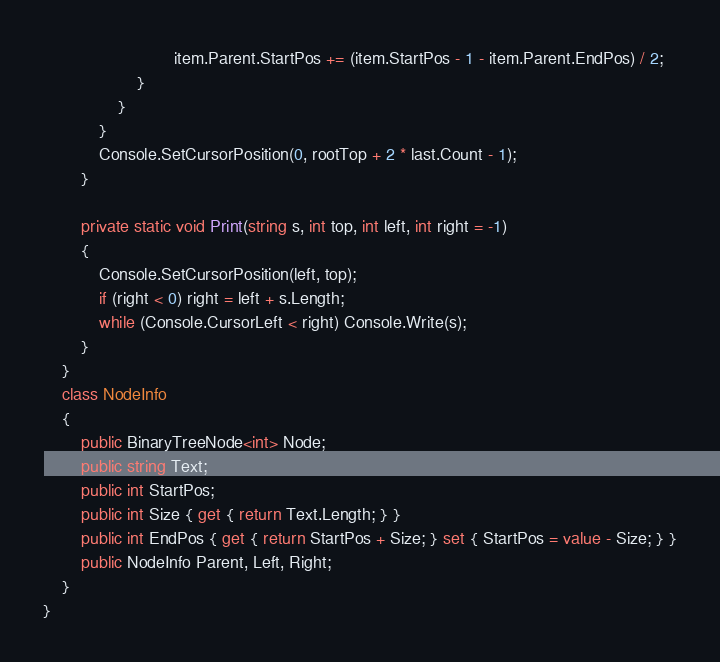<code> <loc_0><loc_0><loc_500><loc_500><_C#_>                            item.Parent.StartPos += (item.StartPos - 1 - item.Parent.EndPos) / 2;
                    }
                }
            }
            Console.SetCursorPosition(0, rootTop + 2 * last.Count - 1);
        }

        private static void Print(string s, int top, int left, int right = -1)
        {
            Console.SetCursorPosition(left, top);
            if (right < 0) right = left + s.Length;
            while (Console.CursorLeft < right) Console.Write(s);
        }
    }
    class NodeInfo
    {
        public BinaryTreeNode<int> Node;
        public string Text;
        public int StartPos;
        public int Size { get { return Text.Length; } }
        public int EndPos { get { return StartPos + Size; } set { StartPos = value - Size; } }
        public NodeInfo Parent, Left, Right;
    }
}
</code> 